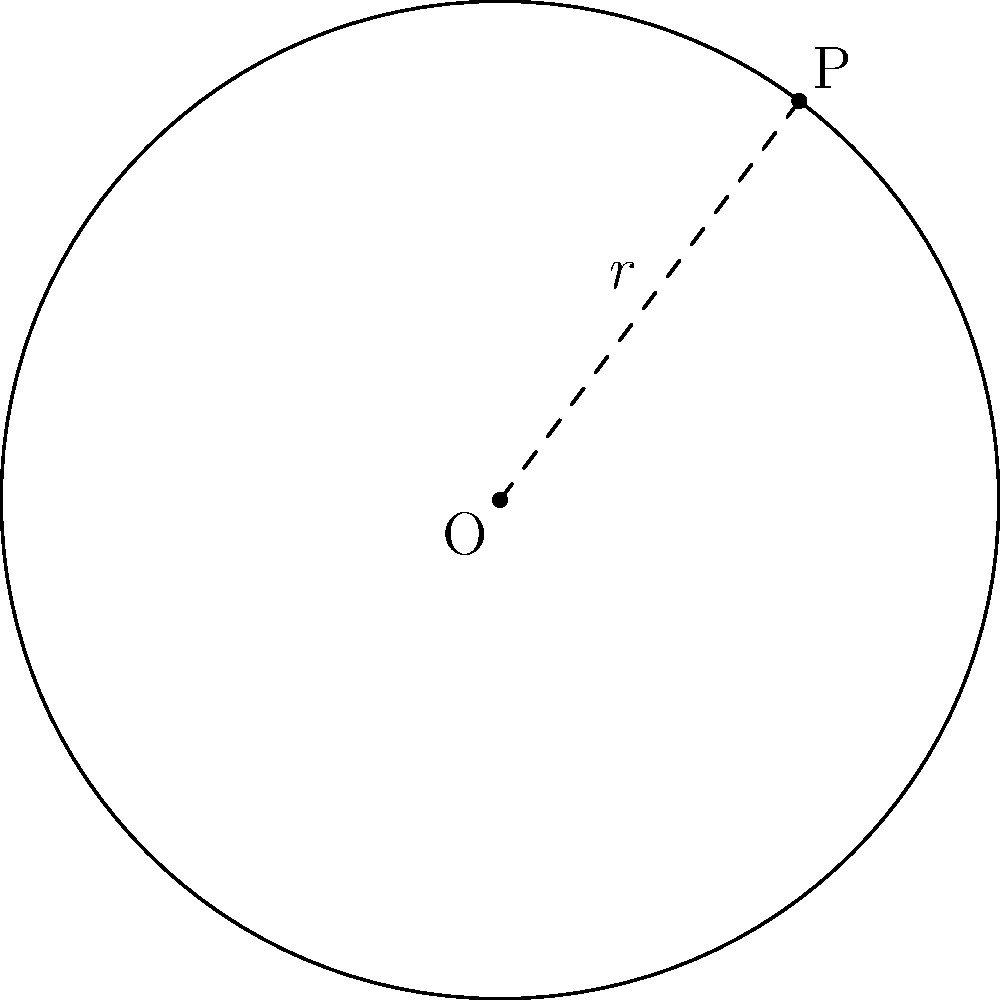As a retired employee from Distinction Group Inc., you recall a project involving circular layouts. Given a circle with center O(0,0) and a point P(3,4) on its circumference, determine the equation of this circle. Let's approach this step-by-step:

1) The general equation of a circle is $(x-h)^2 + (y-k)^2 = r^2$, where (h,k) is the center and r is the radius.

2) We're given that the center is at O(0,0), so h = 0 and k = 0.

3) To find r, we can use the distance formula between O and P:

   $r^2 = (x_P - x_O)^2 + (y_P - y_O)^2$
   $r^2 = (3 - 0)^2 + (4 - 0)^2$
   $r^2 = 3^2 + 4^2 = 9 + 16 = 25$

4) Therefore, $r = \sqrt{25} = 5$

5) Substituting these values into the general equation:

   $(x-0)^2 + (y-0)^2 = 5^2$

6) Simplifying:

   $x^2 + y^2 = 25$

This is the equation of the circle.
Answer: $x^2 + y^2 = 25$ 